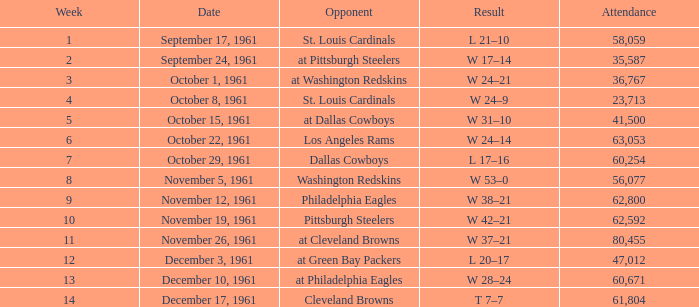What week features a washington redskins' opponent and a crowd exceeding 56,077 in attendance? 0.0. 